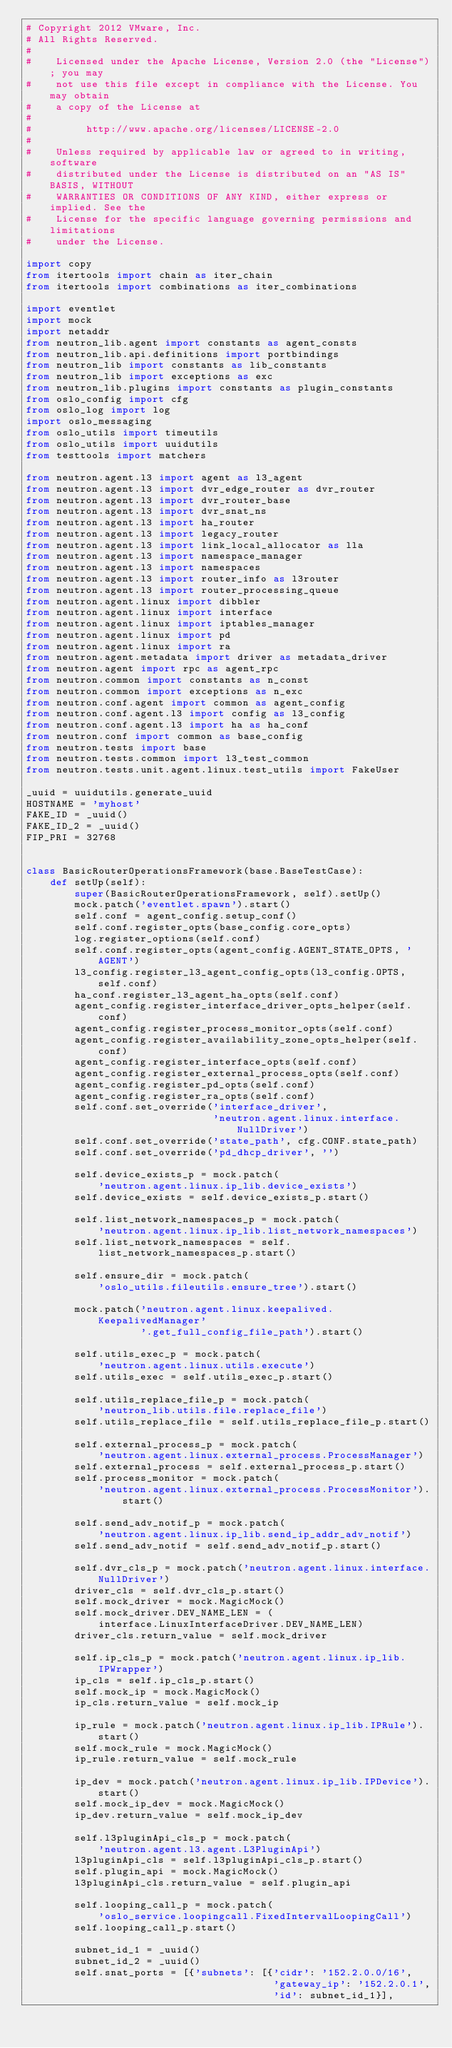Convert code to text. <code><loc_0><loc_0><loc_500><loc_500><_Python_># Copyright 2012 VMware, Inc.
# All Rights Reserved.
#
#    Licensed under the Apache License, Version 2.0 (the "License"); you may
#    not use this file except in compliance with the License. You may obtain
#    a copy of the License at
#
#         http://www.apache.org/licenses/LICENSE-2.0
#
#    Unless required by applicable law or agreed to in writing, software
#    distributed under the License is distributed on an "AS IS" BASIS, WITHOUT
#    WARRANTIES OR CONDITIONS OF ANY KIND, either express or implied. See the
#    License for the specific language governing permissions and limitations
#    under the License.

import copy
from itertools import chain as iter_chain
from itertools import combinations as iter_combinations

import eventlet
import mock
import netaddr
from neutron_lib.agent import constants as agent_consts
from neutron_lib.api.definitions import portbindings
from neutron_lib import constants as lib_constants
from neutron_lib import exceptions as exc
from neutron_lib.plugins import constants as plugin_constants
from oslo_config import cfg
from oslo_log import log
import oslo_messaging
from oslo_utils import timeutils
from oslo_utils import uuidutils
from testtools import matchers

from neutron.agent.l3 import agent as l3_agent
from neutron.agent.l3 import dvr_edge_router as dvr_router
from neutron.agent.l3 import dvr_router_base
from neutron.agent.l3 import dvr_snat_ns
from neutron.agent.l3 import ha_router
from neutron.agent.l3 import legacy_router
from neutron.agent.l3 import link_local_allocator as lla
from neutron.agent.l3 import namespace_manager
from neutron.agent.l3 import namespaces
from neutron.agent.l3 import router_info as l3router
from neutron.agent.l3 import router_processing_queue
from neutron.agent.linux import dibbler
from neutron.agent.linux import interface
from neutron.agent.linux import iptables_manager
from neutron.agent.linux import pd
from neutron.agent.linux import ra
from neutron.agent.metadata import driver as metadata_driver
from neutron.agent import rpc as agent_rpc
from neutron.common import constants as n_const
from neutron.common import exceptions as n_exc
from neutron.conf.agent import common as agent_config
from neutron.conf.agent.l3 import config as l3_config
from neutron.conf.agent.l3 import ha as ha_conf
from neutron.conf import common as base_config
from neutron.tests import base
from neutron.tests.common import l3_test_common
from neutron.tests.unit.agent.linux.test_utils import FakeUser

_uuid = uuidutils.generate_uuid
HOSTNAME = 'myhost'
FAKE_ID = _uuid()
FAKE_ID_2 = _uuid()
FIP_PRI = 32768


class BasicRouterOperationsFramework(base.BaseTestCase):
    def setUp(self):
        super(BasicRouterOperationsFramework, self).setUp()
        mock.patch('eventlet.spawn').start()
        self.conf = agent_config.setup_conf()
        self.conf.register_opts(base_config.core_opts)
        log.register_options(self.conf)
        self.conf.register_opts(agent_config.AGENT_STATE_OPTS, 'AGENT')
        l3_config.register_l3_agent_config_opts(l3_config.OPTS, self.conf)
        ha_conf.register_l3_agent_ha_opts(self.conf)
        agent_config.register_interface_driver_opts_helper(self.conf)
        agent_config.register_process_monitor_opts(self.conf)
        agent_config.register_availability_zone_opts_helper(self.conf)
        agent_config.register_interface_opts(self.conf)
        agent_config.register_external_process_opts(self.conf)
        agent_config.register_pd_opts(self.conf)
        agent_config.register_ra_opts(self.conf)
        self.conf.set_override('interface_driver',
                               'neutron.agent.linux.interface.NullDriver')
        self.conf.set_override('state_path', cfg.CONF.state_path)
        self.conf.set_override('pd_dhcp_driver', '')

        self.device_exists_p = mock.patch(
            'neutron.agent.linux.ip_lib.device_exists')
        self.device_exists = self.device_exists_p.start()

        self.list_network_namespaces_p = mock.patch(
            'neutron.agent.linux.ip_lib.list_network_namespaces')
        self.list_network_namespaces = self.list_network_namespaces_p.start()

        self.ensure_dir = mock.patch(
            'oslo_utils.fileutils.ensure_tree').start()

        mock.patch('neutron.agent.linux.keepalived.KeepalivedManager'
                   '.get_full_config_file_path').start()

        self.utils_exec_p = mock.patch(
            'neutron.agent.linux.utils.execute')
        self.utils_exec = self.utils_exec_p.start()

        self.utils_replace_file_p = mock.patch(
            'neutron_lib.utils.file.replace_file')
        self.utils_replace_file = self.utils_replace_file_p.start()

        self.external_process_p = mock.patch(
            'neutron.agent.linux.external_process.ProcessManager')
        self.external_process = self.external_process_p.start()
        self.process_monitor = mock.patch(
            'neutron.agent.linux.external_process.ProcessMonitor').start()

        self.send_adv_notif_p = mock.patch(
            'neutron.agent.linux.ip_lib.send_ip_addr_adv_notif')
        self.send_adv_notif = self.send_adv_notif_p.start()

        self.dvr_cls_p = mock.patch('neutron.agent.linux.interface.NullDriver')
        driver_cls = self.dvr_cls_p.start()
        self.mock_driver = mock.MagicMock()
        self.mock_driver.DEV_NAME_LEN = (
            interface.LinuxInterfaceDriver.DEV_NAME_LEN)
        driver_cls.return_value = self.mock_driver

        self.ip_cls_p = mock.patch('neutron.agent.linux.ip_lib.IPWrapper')
        ip_cls = self.ip_cls_p.start()
        self.mock_ip = mock.MagicMock()
        ip_cls.return_value = self.mock_ip

        ip_rule = mock.patch('neutron.agent.linux.ip_lib.IPRule').start()
        self.mock_rule = mock.MagicMock()
        ip_rule.return_value = self.mock_rule

        ip_dev = mock.patch('neutron.agent.linux.ip_lib.IPDevice').start()
        self.mock_ip_dev = mock.MagicMock()
        ip_dev.return_value = self.mock_ip_dev

        self.l3pluginApi_cls_p = mock.patch(
            'neutron.agent.l3.agent.L3PluginApi')
        l3pluginApi_cls = self.l3pluginApi_cls_p.start()
        self.plugin_api = mock.MagicMock()
        l3pluginApi_cls.return_value = self.plugin_api

        self.looping_call_p = mock.patch(
            'oslo_service.loopingcall.FixedIntervalLoopingCall')
        self.looping_call_p.start()

        subnet_id_1 = _uuid()
        subnet_id_2 = _uuid()
        self.snat_ports = [{'subnets': [{'cidr': '152.2.0.0/16',
                                         'gateway_ip': '152.2.0.1',
                                         'id': subnet_id_1}],</code> 